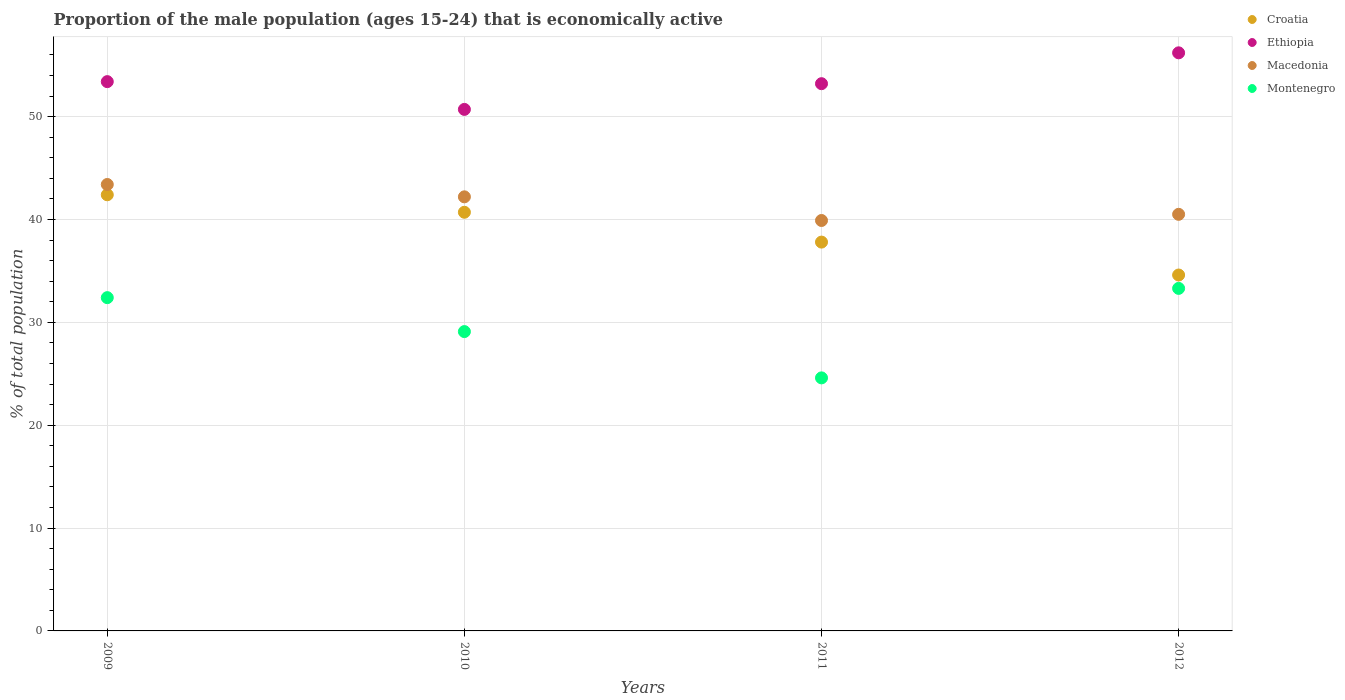How many different coloured dotlines are there?
Your answer should be compact. 4. What is the proportion of the male population that is economically active in Ethiopia in 2012?
Keep it short and to the point. 56.2. Across all years, what is the maximum proportion of the male population that is economically active in Ethiopia?
Make the answer very short. 56.2. Across all years, what is the minimum proportion of the male population that is economically active in Croatia?
Your answer should be compact. 34.6. In which year was the proportion of the male population that is economically active in Croatia maximum?
Provide a succinct answer. 2009. What is the total proportion of the male population that is economically active in Ethiopia in the graph?
Your answer should be compact. 213.5. What is the difference between the proportion of the male population that is economically active in Montenegro in 2009 and that in 2011?
Offer a terse response. 7.8. What is the difference between the proportion of the male population that is economically active in Montenegro in 2012 and the proportion of the male population that is economically active in Croatia in 2010?
Give a very brief answer. -7.4. What is the average proportion of the male population that is economically active in Montenegro per year?
Offer a terse response. 29.85. In the year 2010, what is the difference between the proportion of the male population that is economically active in Ethiopia and proportion of the male population that is economically active in Montenegro?
Your answer should be very brief. 21.6. What is the ratio of the proportion of the male population that is economically active in Montenegro in 2010 to that in 2012?
Give a very brief answer. 0.87. Is the proportion of the male population that is economically active in Ethiopia in 2010 less than that in 2011?
Your response must be concise. Yes. What is the difference between the highest and the second highest proportion of the male population that is economically active in Ethiopia?
Provide a short and direct response. 2.8. What is the difference between the highest and the lowest proportion of the male population that is economically active in Ethiopia?
Offer a terse response. 5.5. In how many years, is the proportion of the male population that is economically active in Ethiopia greater than the average proportion of the male population that is economically active in Ethiopia taken over all years?
Provide a short and direct response. 2. Is it the case that in every year, the sum of the proportion of the male population that is economically active in Croatia and proportion of the male population that is economically active in Macedonia  is greater than the sum of proportion of the male population that is economically active in Ethiopia and proportion of the male population that is economically active in Montenegro?
Your answer should be compact. Yes. Does the proportion of the male population that is economically active in Ethiopia monotonically increase over the years?
Your answer should be very brief. No. Is the proportion of the male population that is economically active in Montenegro strictly greater than the proportion of the male population that is economically active in Croatia over the years?
Ensure brevity in your answer.  No. How many years are there in the graph?
Offer a terse response. 4. What is the difference between two consecutive major ticks on the Y-axis?
Your response must be concise. 10. Are the values on the major ticks of Y-axis written in scientific E-notation?
Provide a short and direct response. No. Does the graph contain grids?
Keep it short and to the point. Yes. Where does the legend appear in the graph?
Offer a very short reply. Top right. How are the legend labels stacked?
Your response must be concise. Vertical. What is the title of the graph?
Make the answer very short. Proportion of the male population (ages 15-24) that is economically active. Does "East Asia (all income levels)" appear as one of the legend labels in the graph?
Offer a very short reply. No. What is the label or title of the Y-axis?
Make the answer very short. % of total population. What is the % of total population of Croatia in 2009?
Provide a succinct answer. 42.4. What is the % of total population in Ethiopia in 2009?
Offer a very short reply. 53.4. What is the % of total population in Macedonia in 2009?
Offer a terse response. 43.4. What is the % of total population of Montenegro in 2009?
Provide a succinct answer. 32.4. What is the % of total population of Croatia in 2010?
Provide a succinct answer. 40.7. What is the % of total population in Ethiopia in 2010?
Make the answer very short. 50.7. What is the % of total population of Macedonia in 2010?
Your response must be concise. 42.2. What is the % of total population of Montenegro in 2010?
Your answer should be very brief. 29.1. What is the % of total population of Croatia in 2011?
Your answer should be compact. 37.8. What is the % of total population in Ethiopia in 2011?
Your answer should be very brief. 53.2. What is the % of total population of Macedonia in 2011?
Offer a very short reply. 39.9. What is the % of total population of Montenegro in 2011?
Your answer should be compact. 24.6. What is the % of total population of Croatia in 2012?
Keep it short and to the point. 34.6. What is the % of total population in Ethiopia in 2012?
Your answer should be very brief. 56.2. What is the % of total population of Macedonia in 2012?
Provide a succinct answer. 40.5. What is the % of total population of Montenegro in 2012?
Make the answer very short. 33.3. Across all years, what is the maximum % of total population of Croatia?
Offer a terse response. 42.4. Across all years, what is the maximum % of total population of Ethiopia?
Offer a terse response. 56.2. Across all years, what is the maximum % of total population in Macedonia?
Provide a short and direct response. 43.4. Across all years, what is the maximum % of total population of Montenegro?
Give a very brief answer. 33.3. Across all years, what is the minimum % of total population in Croatia?
Make the answer very short. 34.6. Across all years, what is the minimum % of total population of Ethiopia?
Your answer should be very brief. 50.7. Across all years, what is the minimum % of total population of Macedonia?
Your answer should be compact. 39.9. Across all years, what is the minimum % of total population of Montenegro?
Your answer should be compact. 24.6. What is the total % of total population of Croatia in the graph?
Your response must be concise. 155.5. What is the total % of total population of Ethiopia in the graph?
Your response must be concise. 213.5. What is the total % of total population of Macedonia in the graph?
Make the answer very short. 166. What is the total % of total population in Montenegro in the graph?
Your answer should be compact. 119.4. What is the difference between the % of total population of Croatia in 2009 and that in 2010?
Ensure brevity in your answer.  1.7. What is the difference between the % of total population of Ethiopia in 2009 and that in 2010?
Offer a terse response. 2.7. What is the difference between the % of total population in Macedonia in 2009 and that in 2010?
Offer a very short reply. 1.2. What is the difference between the % of total population in Montenegro in 2009 and that in 2010?
Make the answer very short. 3.3. What is the difference between the % of total population of Ethiopia in 2009 and that in 2011?
Give a very brief answer. 0.2. What is the difference between the % of total population of Croatia in 2009 and that in 2012?
Your answer should be compact. 7.8. What is the difference between the % of total population in Macedonia in 2009 and that in 2012?
Give a very brief answer. 2.9. What is the difference between the % of total population in Croatia in 2010 and that in 2011?
Provide a short and direct response. 2.9. What is the difference between the % of total population in Macedonia in 2010 and that in 2012?
Your answer should be compact. 1.7. What is the difference between the % of total population of Croatia in 2009 and the % of total population of Macedonia in 2010?
Your answer should be very brief. 0.2. What is the difference between the % of total population in Croatia in 2009 and the % of total population in Montenegro in 2010?
Ensure brevity in your answer.  13.3. What is the difference between the % of total population of Ethiopia in 2009 and the % of total population of Montenegro in 2010?
Give a very brief answer. 24.3. What is the difference between the % of total population of Croatia in 2009 and the % of total population of Macedonia in 2011?
Give a very brief answer. 2.5. What is the difference between the % of total population of Croatia in 2009 and the % of total population of Montenegro in 2011?
Your response must be concise. 17.8. What is the difference between the % of total population in Ethiopia in 2009 and the % of total population in Macedonia in 2011?
Give a very brief answer. 13.5. What is the difference between the % of total population in Ethiopia in 2009 and the % of total population in Montenegro in 2011?
Offer a very short reply. 28.8. What is the difference between the % of total population of Macedonia in 2009 and the % of total population of Montenegro in 2011?
Ensure brevity in your answer.  18.8. What is the difference between the % of total population of Croatia in 2009 and the % of total population of Ethiopia in 2012?
Your answer should be very brief. -13.8. What is the difference between the % of total population of Croatia in 2009 and the % of total population of Macedonia in 2012?
Your answer should be very brief. 1.9. What is the difference between the % of total population of Croatia in 2009 and the % of total population of Montenegro in 2012?
Your response must be concise. 9.1. What is the difference between the % of total population in Ethiopia in 2009 and the % of total population in Macedonia in 2012?
Keep it short and to the point. 12.9. What is the difference between the % of total population in Ethiopia in 2009 and the % of total population in Montenegro in 2012?
Offer a terse response. 20.1. What is the difference between the % of total population in Macedonia in 2009 and the % of total population in Montenegro in 2012?
Make the answer very short. 10.1. What is the difference between the % of total population of Croatia in 2010 and the % of total population of Ethiopia in 2011?
Ensure brevity in your answer.  -12.5. What is the difference between the % of total population in Croatia in 2010 and the % of total population in Macedonia in 2011?
Give a very brief answer. 0.8. What is the difference between the % of total population of Croatia in 2010 and the % of total population of Montenegro in 2011?
Provide a short and direct response. 16.1. What is the difference between the % of total population in Ethiopia in 2010 and the % of total population in Montenegro in 2011?
Offer a terse response. 26.1. What is the difference between the % of total population in Macedonia in 2010 and the % of total population in Montenegro in 2011?
Keep it short and to the point. 17.6. What is the difference between the % of total population in Croatia in 2010 and the % of total population in Ethiopia in 2012?
Provide a short and direct response. -15.5. What is the difference between the % of total population in Ethiopia in 2010 and the % of total population in Macedonia in 2012?
Provide a succinct answer. 10.2. What is the difference between the % of total population of Croatia in 2011 and the % of total population of Ethiopia in 2012?
Your answer should be compact. -18.4. What is the difference between the % of total population of Croatia in 2011 and the % of total population of Macedonia in 2012?
Provide a short and direct response. -2.7. What is the difference between the % of total population of Ethiopia in 2011 and the % of total population of Macedonia in 2012?
Give a very brief answer. 12.7. What is the difference between the % of total population of Ethiopia in 2011 and the % of total population of Montenegro in 2012?
Give a very brief answer. 19.9. What is the average % of total population in Croatia per year?
Ensure brevity in your answer.  38.88. What is the average % of total population of Ethiopia per year?
Provide a succinct answer. 53.38. What is the average % of total population in Macedonia per year?
Offer a very short reply. 41.5. What is the average % of total population of Montenegro per year?
Ensure brevity in your answer.  29.85. In the year 2009, what is the difference between the % of total population of Croatia and % of total population of Ethiopia?
Provide a succinct answer. -11. In the year 2009, what is the difference between the % of total population in Ethiopia and % of total population in Macedonia?
Provide a short and direct response. 10. In the year 2009, what is the difference between the % of total population of Ethiopia and % of total population of Montenegro?
Your answer should be compact. 21. In the year 2010, what is the difference between the % of total population of Croatia and % of total population of Ethiopia?
Your answer should be compact. -10. In the year 2010, what is the difference between the % of total population in Ethiopia and % of total population in Montenegro?
Offer a terse response. 21.6. In the year 2011, what is the difference between the % of total population in Croatia and % of total population in Ethiopia?
Provide a short and direct response. -15.4. In the year 2011, what is the difference between the % of total population in Croatia and % of total population in Macedonia?
Offer a very short reply. -2.1. In the year 2011, what is the difference between the % of total population in Croatia and % of total population in Montenegro?
Ensure brevity in your answer.  13.2. In the year 2011, what is the difference between the % of total population in Ethiopia and % of total population in Macedonia?
Your response must be concise. 13.3. In the year 2011, what is the difference between the % of total population of Ethiopia and % of total population of Montenegro?
Your response must be concise. 28.6. In the year 2011, what is the difference between the % of total population of Macedonia and % of total population of Montenegro?
Your answer should be compact. 15.3. In the year 2012, what is the difference between the % of total population of Croatia and % of total population of Ethiopia?
Ensure brevity in your answer.  -21.6. In the year 2012, what is the difference between the % of total population in Croatia and % of total population in Macedonia?
Provide a short and direct response. -5.9. In the year 2012, what is the difference between the % of total population in Ethiopia and % of total population in Montenegro?
Give a very brief answer. 22.9. In the year 2012, what is the difference between the % of total population in Macedonia and % of total population in Montenegro?
Provide a succinct answer. 7.2. What is the ratio of the % of total population in Croatia in 2009 to that in 2010?
Make the answer very short. 1.04. What is the ratio of the % of total population of Ethiopia in 2009 to that in 2010?
Make the answer very short. 1.05. What is the ratio of the % of total population of Macedonia in 2009 to that in 2010?
Ensure brevity in your answer.  1.03. What is the ratio of the % of total population of Montenegro in 2009 to that in 2010?
Give a very brief answer. 1.11. What is the ratio of the % of total population in Croatia in 2009 to that in 2011?
Keep it short and to the point. 1.12. What is the ratio of the % of total population in Ethiopia in 2009 to that in 2011?
Ensure brevity in your answer.  1. What is the ratio of the % of total population of Macedonia in 2009 to that in 2011?
Give a very brief answer. 1.09. What is the ratio of the % of total population in Montenegro in 2009 to that in 2011?
Your answer should be compact. 1.32. What is the ratio of the % of total population of Croatia in 2009 to that in 2012?
Provide a short and direct response. 1.23. What is the ratio of the % of total population of Ethiopia in 2009 to that in 2012?
Your answer should be very brief. 0.95. What is the ratio of the % of total population in Macedonia in 2009 to that in 2012?
Offer a terse response. 1.07. What is the ratio of the % of total population of Montenegro in 2009 to that in 2012?
Provide a succinct answer. 0.97. What is the ratio of the % of total population of Croatia in 2010 to that in 2011?
Your answer should be very brief. 1.08. What is the ratio of the % of total population of Ethiopia in 2010 to that in 2011?
Your answer should be very brief. 0.95. What is the ratio of the % of total population of Macedonia in 2010 to that in 2011?
Make the answer very short. 1.06. What is the ratio of the % of total population in Montenegro in 2010 to that in 2011?
Ensure brevity in your answer.  1.18. What is the ratio of the % of total population of Croatia in 2010 to that in 2012?
Ensure brevity in your answer.  1.18. What is the ratio of the % of total population of Ethiopia in 2010 to that in 2012?
Provide a succinct answer. 0.9. What is the ratio of the % of total population of Macedonia in 2010 to that in 2012?
Your response must be concise. 1.04. What is the ratio of the % of total population of Montenegro in 2010 to that in 2012?
Give a very brief answer. 0.87. What is the ratio of the % of total population in Croatia in 2011 to that in 2012?
Offer a very short reply. 1.09. What is the ratio of the % of total population in Ethiopia in 2011 to that in 2012?
Make the answer very short. 0.95. What is the ratio of the % of total population in Macedonia in 2011 to that in 2012?
Your answer should be very brief. 0.99. What is the ratio of the % of total population of Montenegro in 2011 to that in 2012?
Offer a terse response. 0.74. What is the difference between the highest and the second highest % of total population of Ethiopia?
Keep it short and to the point. 2.8. What is the difference between the highest and the second highest % of total population in Montenegro?
Your answer should be very brief. 0.9. What is the difference between the highest and the lowest % of total population of Croatia?
Your response must be concise. 7.8. What is the difference between the highest and the lowest % of total population of Montenegro?
Keep it short and to the point. 8.7. 